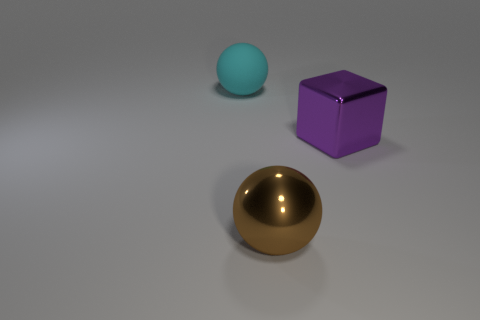Add 2 red rubber cylinders. How many objects exist? 5 Subtract all balls. How many objects are left? 1 Add 1 big brown rubber cylinders. How many big brown rubber cylinders exist? 1 Subtract 0 blue blocks. How many objects are left? 3 Subtract all large shiny balls. Subtract all big cyan objects. How many objects are left? 1 Add 3 brown shiny objects. How many brown shiny objects are left? 4 